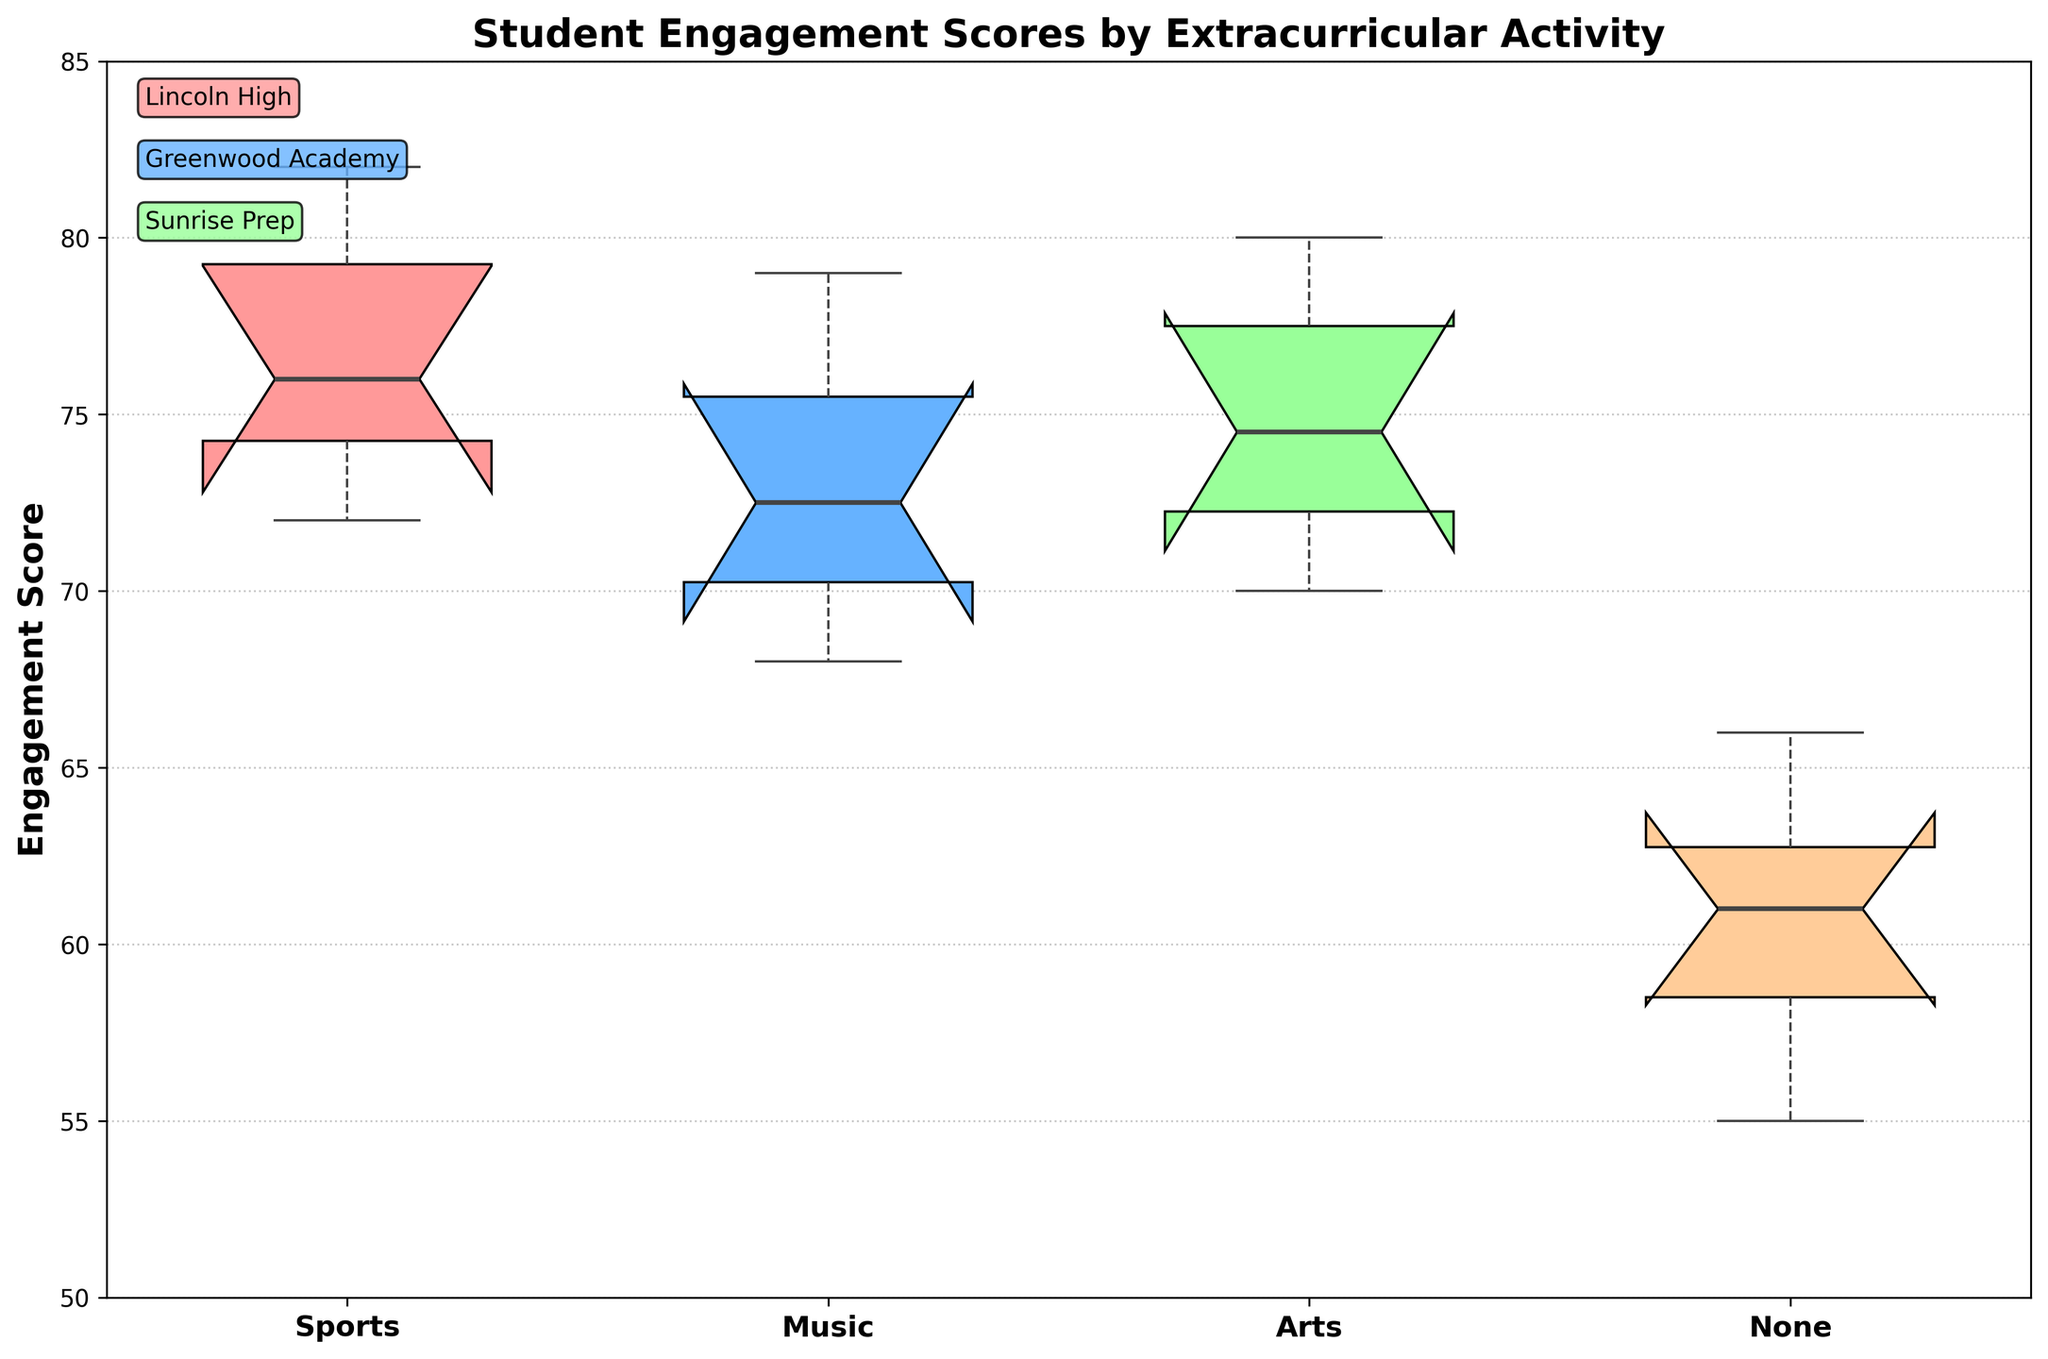What is the title of the plot? The title of the plot can be found at the top of the figure. It reads "Student Engagement Scores by Extracurricular Activity".
Answer: Student Engagement Scores by Extracurricular Activity What are the activities displayed on the x-axis? The x-axis labels are visible below the boxes in the plot. They are "Sports", "Music", "Arts", and "None".
Answer: Sports, Music, Arts, None Which activity shows the highest median engagement score? The median of each activity is represented by the line in the middle of each box. The "Sports" activity has the highest median, as this line is higher than the medians of the other activities.
Answer: Sports What is the approximate range of engagement scores for students participating in sports? To determine the range, look at the minimum and maximum whisker values for the "Sports" box. The whiskers extend from approximately 72 to 82.
Answer: 72 to 82 How do the engagement scores for students with no activities compare with those involved in music? To compare, look at the positions of the boxes and medians for "None" and "Music". The "Music" box has a higher median and overall range compared to "None".
Answer: Music has higher scores What is the purpose of the notches in the box plots? The notches provide a way to assess the statistical significance between medians. If the notches of two boxes overlap, it suggests their medians are not significantly different.
Answer: Assess significance between medians Are there any outliers in the data, and if so, for which activity? Outliers are marked by individual points outside the whiskers. There are no distinct points outside the whiskers for any activity, indicating no outliers.
Answer: No outliers Which school shows the highest engagement score and which activity is it associated with? By looking at the legend near the top of the boxes, it appears Greenwood Academy’s "Sports" activity might have the highest scores, with engagement scores generally high in Greenwood Academy mentioned in the legend.
Answer: Greenwood Academy, Sports Do students engage more in arts in Year 2 compared to Year 1? This requires comparing the engagement scores of "Arts" in Year 1 and Year 2 across all schools. While the plot does not separate them by year, an overall slight increase in "Arts" scores in Year 2 can be noticed.
Answer: Yes What is the range of the y-axis on the plot? The y-axis labels show the engagement scores from 50 to 85.
Answer: 50 to 85 